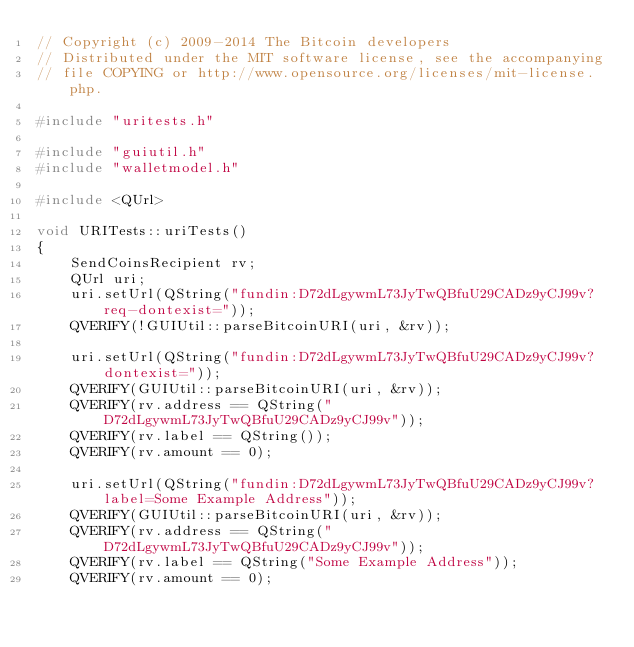Convert code to text. <code><loc_0><loc_0><loc_500><loc_500><_C++_>// Copyright (c) 2009-2014 The Bitcoin developers
// Distributed under the MIT software license, see the accompanying
// file COPYING or http://www.opensource.org/licenses/mit-license.php.

#include "uritests.h"

#include "guiutil.h"
#include "walletmodel.h"

#include <QUrl>

void URITests::uriTests()
{
    SendCoinsRecipient rv;
    QUrl uri;
    uri.setUrl(QString("fundin:D72dLgywmL73JyTwQBfuU29CADz9yCJ99v?req-dontexist="));
    QVERIFY(!GUIUtil::parseBitcoinURI(uri, &rv));

    uri.setUrl(QString("fundin:D72dLgywmL73JyTwQBfuU29CADz9yCJ99v?dontexist="));
    QVERIFY(GUIUtil::parseBitcoinURI(uri, &rv));
    QVERIFY(rv.address == QString("D72dLgywmL73JyTwQBfuU29CADz9yCJ99v"));
    QVERIFY(rv.label == QString());
    QVERIFY(rv.amount == 0);

    uri.setUrl(QString("fundin:D72dLgywmL73JyTwQBfuU29CADz9yCJ99v?label=Some Example Address"));
    QVERIFY(GUIUtil::parseBitcoinURI(uri, &rv));
    QVERIFY(rv.address == QString("D72dLgywmL73JyTwQBfuU29CADz9yCJ99v"));
    QVERIFY(rv.label == QString("Some Example Address"));
    QVERIFY(rv.amount == 0);
</code> 